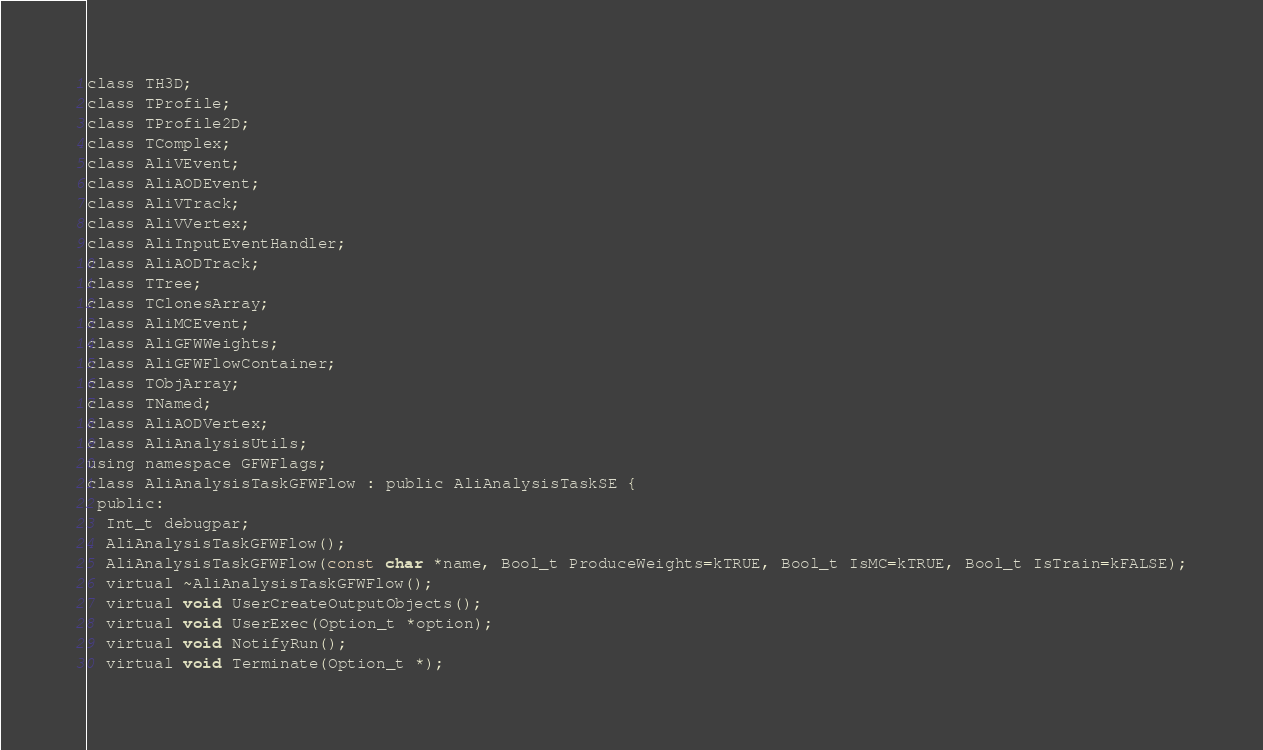<code> <loc_0><loc_0><loc_500><loc_500><_C_>class TH3D;
class TProfile;
class TProfile2D;
class TComplex;
class AliVEvent;
class AliAODEvent;
class AliVTrack;
class AliVVertex;
class AliInputEventHandler;
class AliAODTrack;
class TTree;
class TClonesArray;
class AliMCEvent;
class AliGFWWeights;
class AliGFWFlowContainer;
class TObjArray;
class TNamed;
class AliAODVertex;
class AliAnalysisUtils;
using namespace GFWFlags;
class AliAnalysisTaskGFWFlow : public AliAnalysisTaskSE {
 public:
  Int_t debugpar;
  AliAnalysisTaskGFWFlow();
  AliAnalysisTaskGFWFlow(const char *name, Bool_t ProduceWeights=kTRUE, Bool_t IsMC=kTRUE, Bool_t IsTrain=kFALSE);
  virtual ~AliAnalysisTaskGFWFlow();
  virtual void UserCreateOutputObjects();
  virtual void UserExec(Option_t *option);
  virtual void NotifyRun();
  virtual void Terminate(Option_t *);</code> 